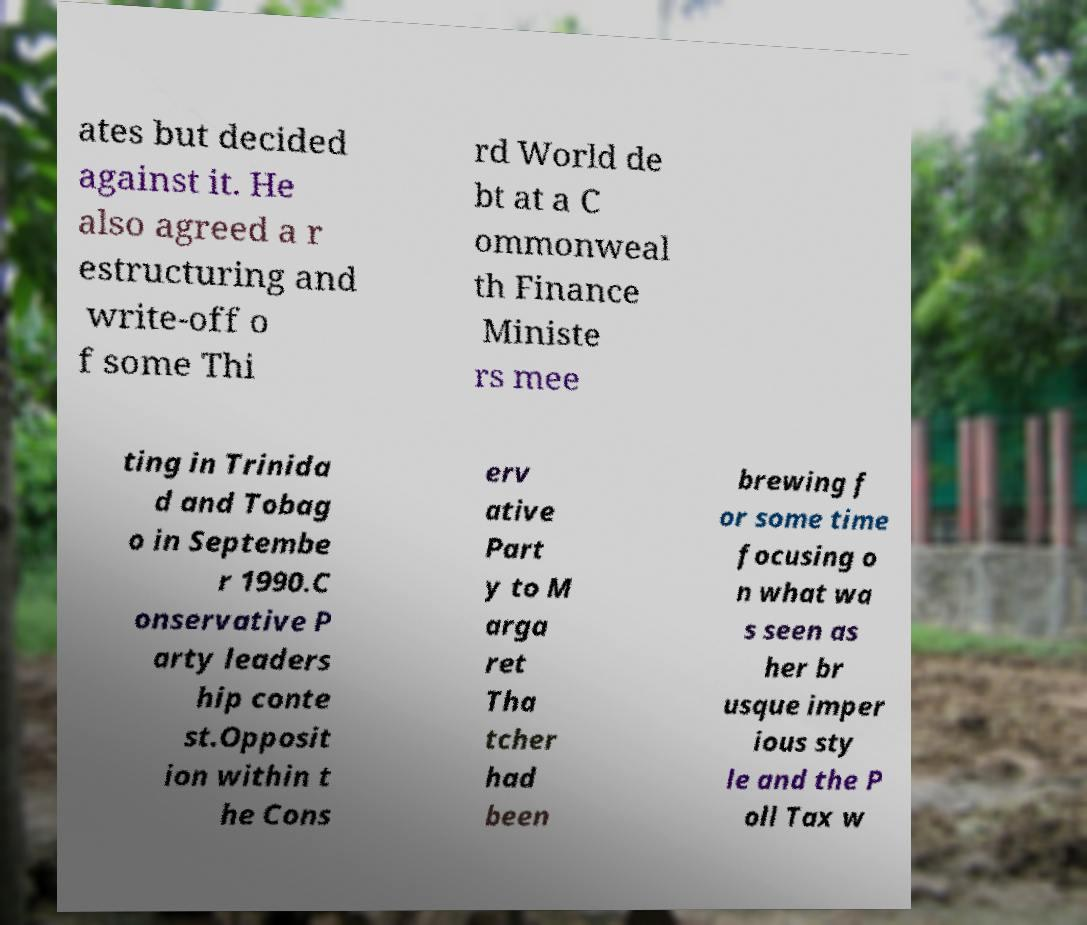For documentation purposes, I need the text within this image transcribed. Could you provide that? ates but decided against it. He also agreed a r estructuring and write-off o f some Thi rd World de bt at a C ommonweal th Finance Ministe rs mee ting in Trinida d and Tobag o in Septembe r 1990.C onservative P arty leaders hip conte st.Opposit ion within t he Cons erv ative Part y to M arga ret Tha tcher had been brewing f or some time focusing o n what wa s seen as her br usque imper ious sty le and the P oll Tax w 